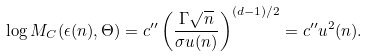<formula> <loc_0><loc_0><loc_500><loc_500>\log M _ { C } ( \epsilon ( n ) , \Theta ) = c ^ { \prime \prime } \left ( \frac { \Gamma \sqrt { n } } { \sigma u ( n ) } \right ) ^ { ( d - 1 ) / 2 } = c ^ { \prime \prime } u ^ { 2 } ( n ) .</formula> 